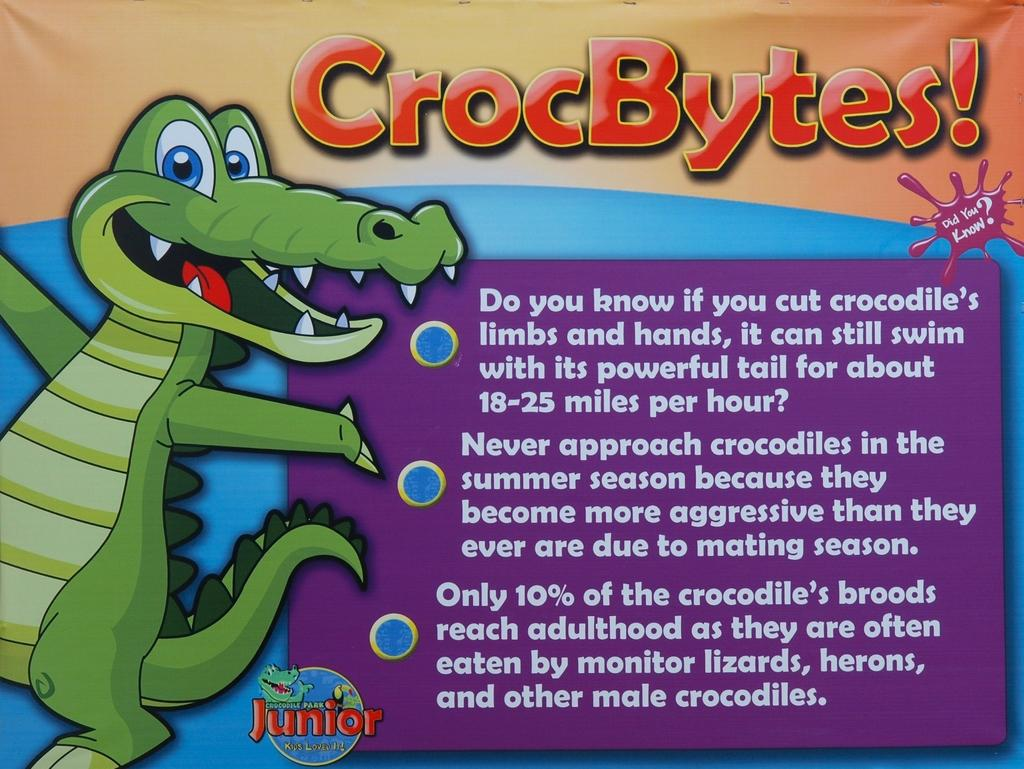What type of visual is the image? The image is a poster. What is depicted on the left side of the poster? There is a drawing of a crocodile on the left side of the poster. What information is present on the poster besides the drawing? There is a name, text, and a logo on the poster. How many baseballs can be seen in the image? There are no baseballs present in the image. What type of error is depicted in the image? There is no error depicted in the image; it features a drawing of a crocodile, a name, text, and a logo. 